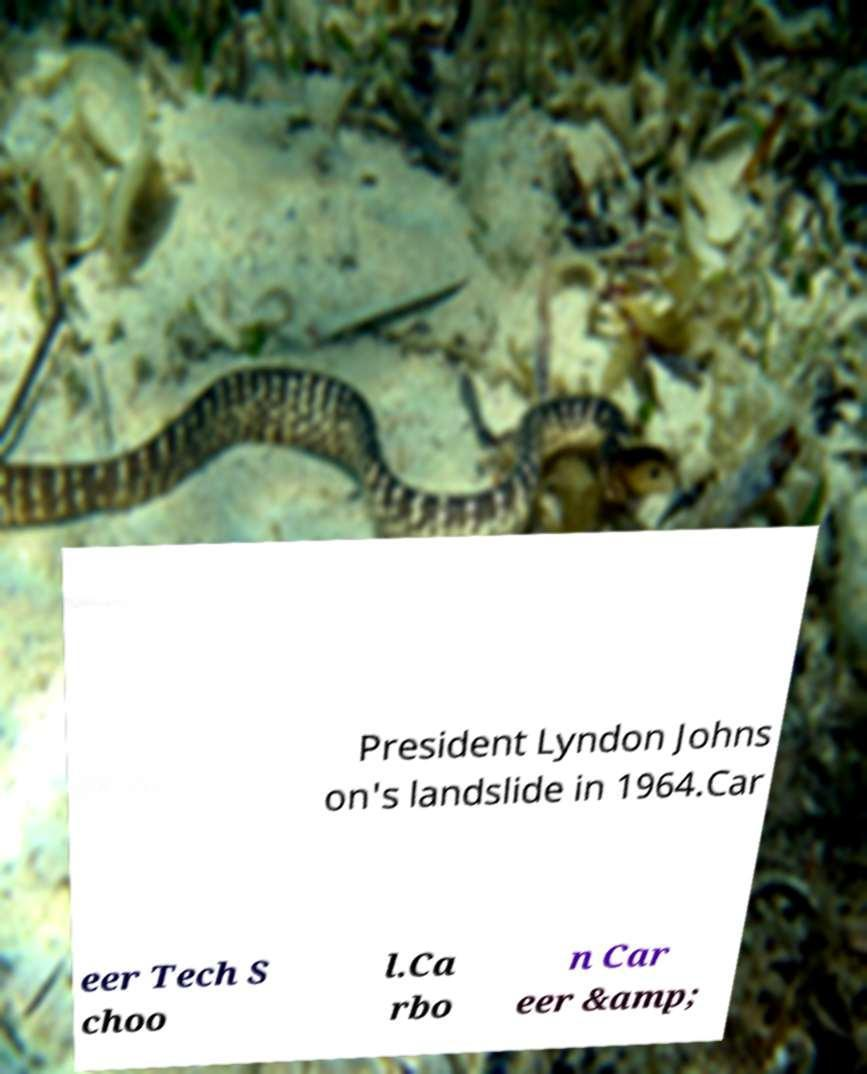Could you assist in decoding the text presented in this image and type it out clearly? President Lyndon Johns on's landslide in 1964.Car eer Tech S choo l.Ca rbo n Car eer &amp; 